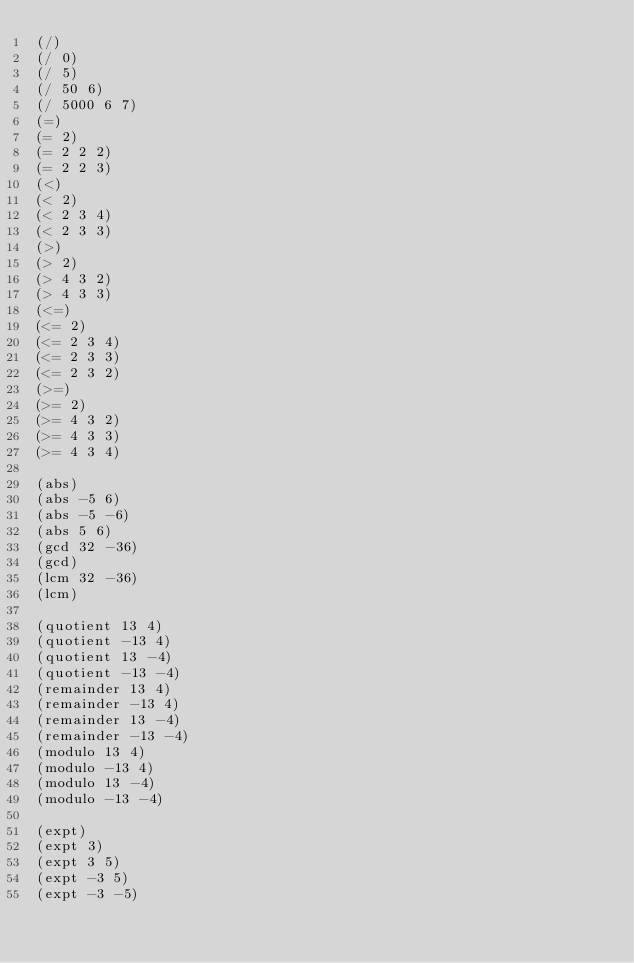<code> <loc_0><loc_0><loc_500><loc_500><_Scheme_>(/)
(/ 0)
(/ 5)
(/ 50 6)
(/ 5000 6 7)
(=)
(= 2)
(= 2 2 2)
(= 2 2 3)
(<)
(< 2)
(< 2 3 4)
(< 2 3 3)
(>)
(> 2)
(> 4 3 2)
(> 4 3 3)
(<=)
(<= 2)
(<= 2 3 4)
(<= 2 3 3)
(<= 2 3 2)
(>=)
(>= 2)
(>= 4 3 2)
(>= 4 3 3)
(>= 4 3 4)

(abs)
(abs -5 6)
(abs -5 -6)
(abs 5 6)
(gcd 32 -36)
(gcd)
(lcm 32 -36)
(lcm)

(quotient 13 4)
(quotient -13 4)
(quotient 13 -4)
(quotient -13 -4)
(remainder 13 4)
(remainder -13 4)
(remainder 13 -4)
(remainder -13 -4)
(modulo 13 4)
(modulo -13 4)
(modulo 13 -4)
(modulo -13 -4)

(expt)
(expt 3)
(expt 3 5)
(expt -3 5)
(expt -3 -5)
</code> 